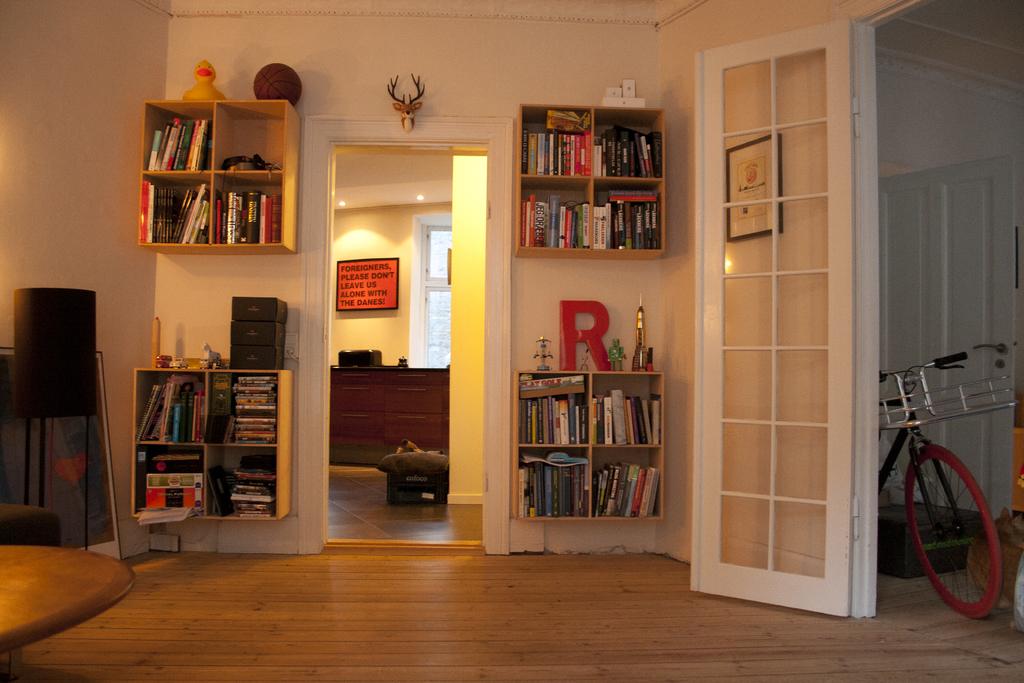What is the big red letter on the shelf?
Provide a short and direct response. R. Which letter is the giant red letter?
Offer a very short reply. R. 